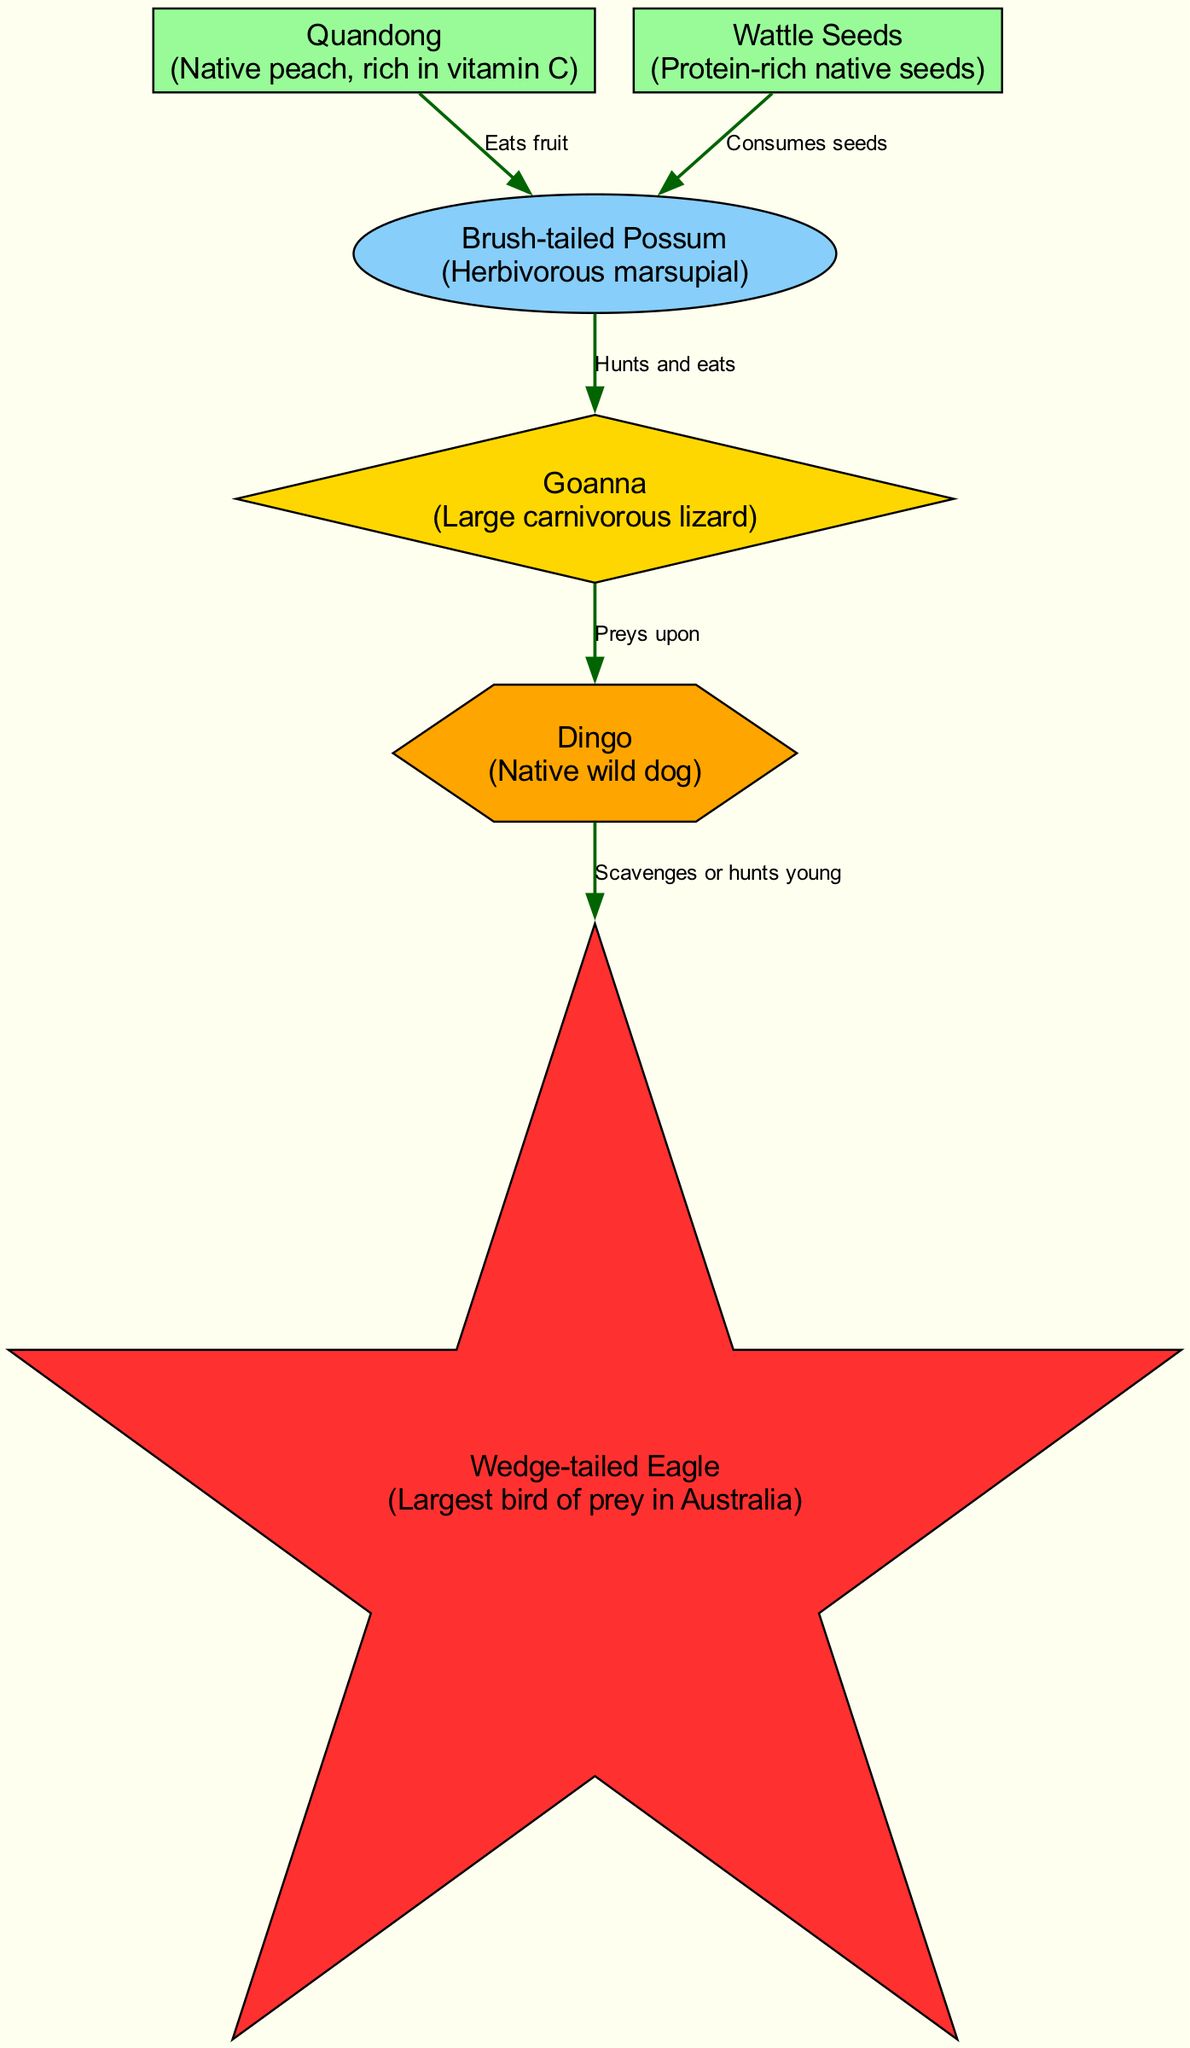What is the apex predator in this food chain? The apex predator is the topmost consumer that has no natural enemies within the food chain. In the diagram, the node labeled "Wedge-tailed Eagle" is categorized as the apex predator, which means it feeds on other animals without being preyed upon in this context.
Answer: Wedge-tailed Eagle How many producers are included in this food chain? Producers are organisms that can create their own food through photosynthesis or similar processes. In this diagram, there are two nodes labeled as producers: "Quandong" and "Wattle Seeds." Counting these nodes gives us the total number of producers.
Answer: 2 What does the Brush-tailed Possum eat according to the diagram? The diagram indicates that the Brush-tailed Possum consumes both Quandong and Wattle Seeds. By reviewing the relationships originating from the Brush-tailed Possum, we can identify these food sources.
Answer: Quandong and Wattle Seeds Which consumer preys upon the Goanna? The Goanna is a secondary consumer and is depicted in the diagram as being preyed upon by the Dingo. By tracing the arrow relationship leading from Goanna, we identify the Dingo as its predator.
Answer: Dingo Out of the secondary and tertiary consumers, which one is considered carnivorous? The Dingo is classified as a tertiary consumer and is a carnivorous animal, while the Goanna, as a secondary consumer, is also carnivorous but is specifically a large lizard. The primary differentiation lies in their roles within the food chain. The question is asking for the carnivorous classification of these consumers, where both qualify, but the clear distinction as the apex of carnivorous behavior is inherently given to Dingo due to its position.
Answer: Dingo What relationship does the Dingo have with the Wedge-tailed Eagle? According to the food chain diagram, the Dingo either scavenges from or hunts young Wedge-tailed Eagles. This specifies a specific kind of interaction where Dingo may either pose a food source or be a competitor for the Wedge-tailed Eagle's offspring.
Answer: Scavenges or hunts young How many relationships are depicted in the food chain diagram? To find the total number of relationships, we count all arrows that connect different nodes, representing feeding relationships. In the diagram, there are five relationships provided between the producers and consumers, resulting in the final count of relationships shown.
Answer: 5 What type of consumer is the Brush-tailed Possum? The Brush-tailed Possum is defined in the diagram as a primary consumer, which means it primarily feeds on producers, in this case, the Quandong and Wattle Seeds. This classification is indicated by its position in the food chain diagram, connecting producers to secondary consumers.
Answer: Primary Consumer 